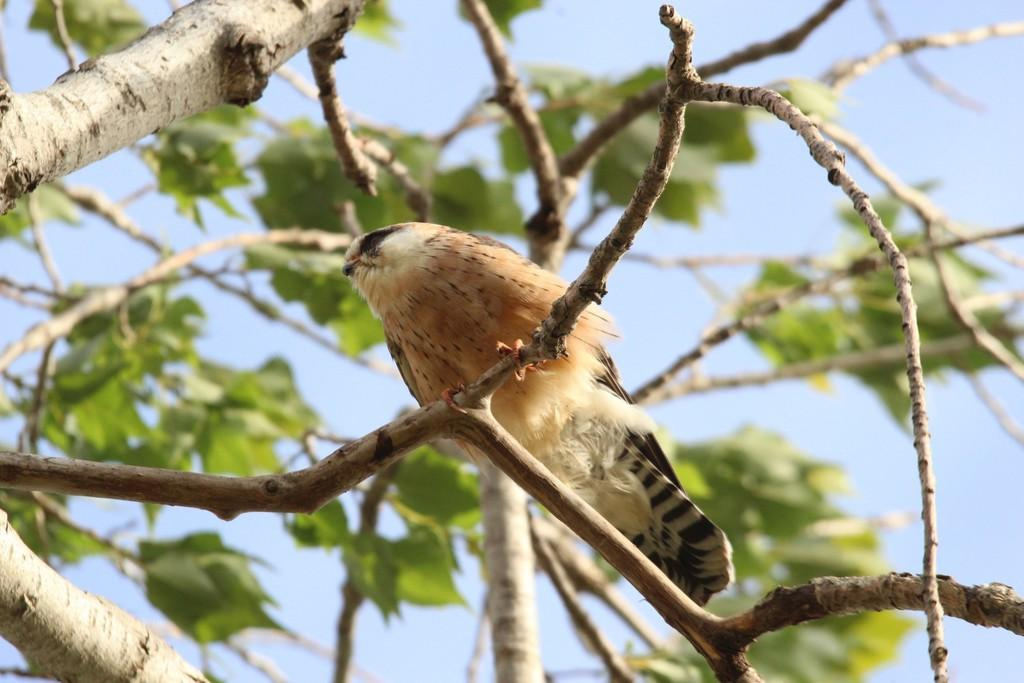What is the main subject in the center of the image? There are branches with leaves in the center of the image. Is there any wildlife present in the image? Yes, there is a bird on one of the branches. What can be seen in the background of the image? The sky is visible in the background of the image. What type of toothpaste is being used to clean the bird's beak in the image? There is no toothpaste or cleaning activity present in the image; it features branches with leaves and a bird. 